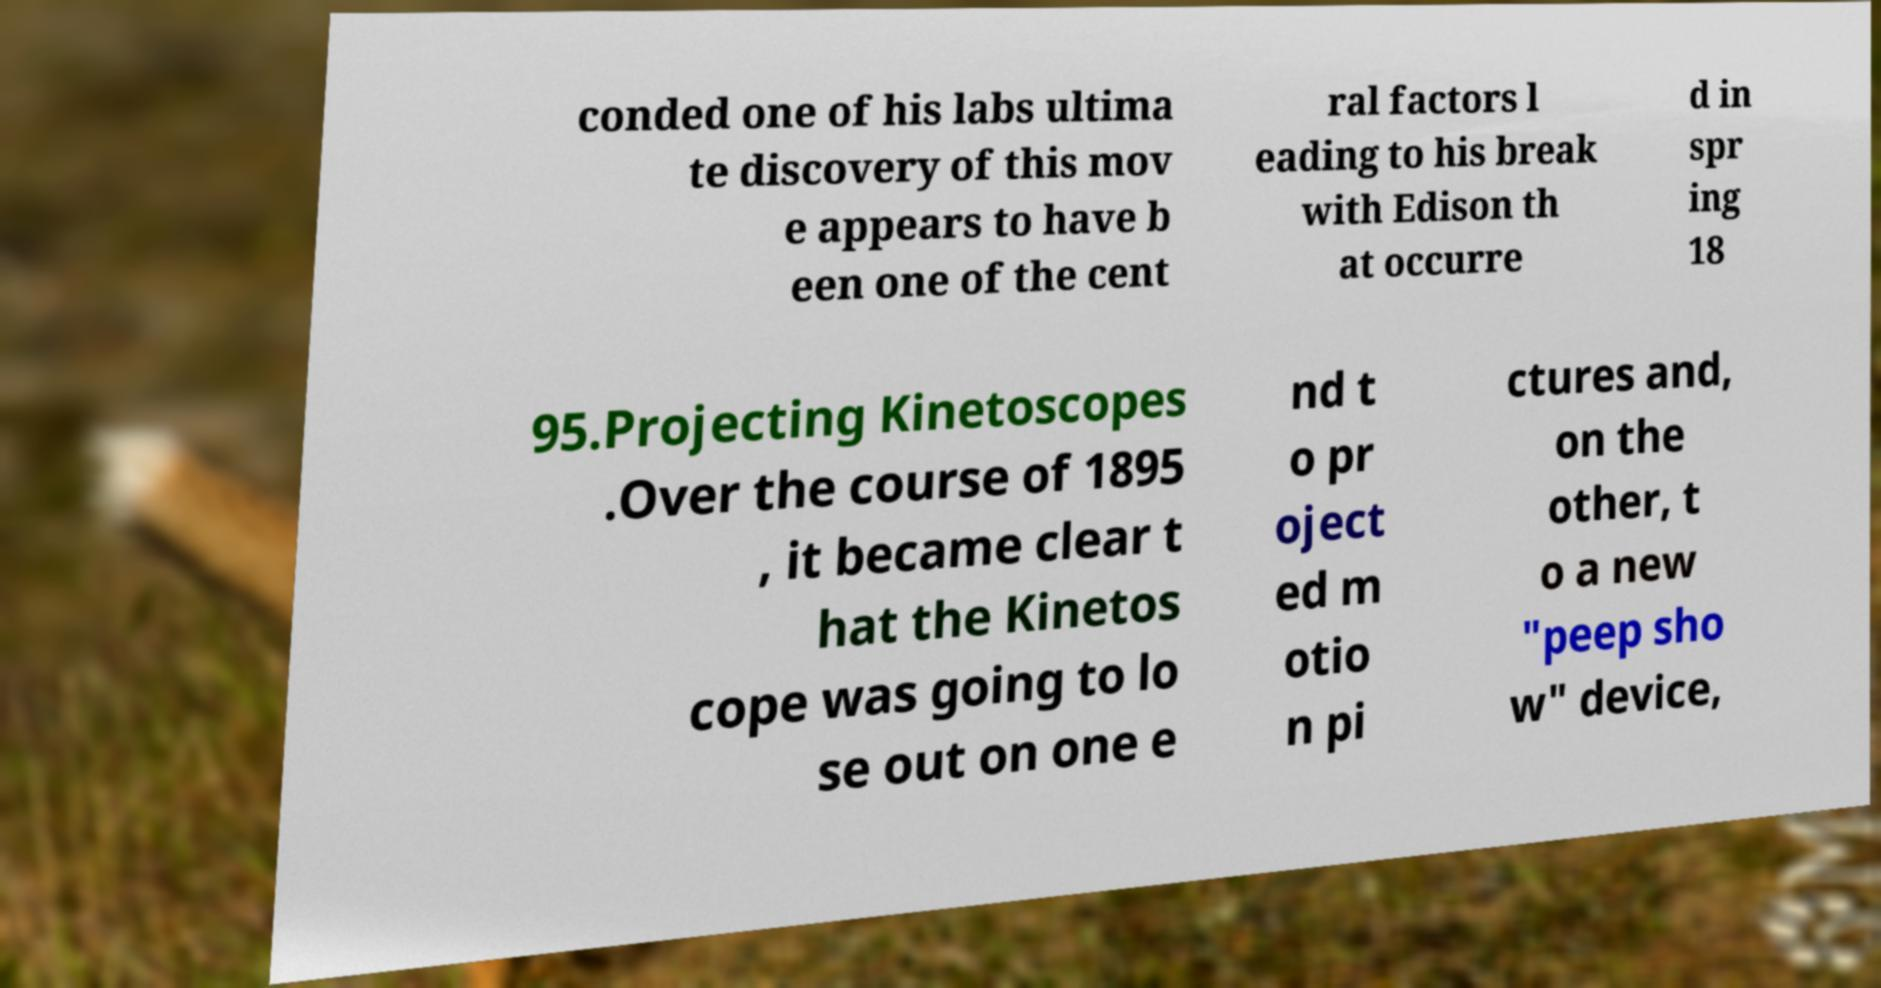Can you accurately transcribe the text from the provided image for me? conded one of his labs ultima te discovery of this mov e appears to have b een one of the cent ral factors l eading to his break with Edison th at occurre d in spr ing 18 95.Projecting Kinetoscopes .Over the course of 1895 , it became clear t hat the Kinetos cope was going to lo se out on one e nd t o pr oject ed m otio n pi ctures and, on the other, t o a new "peep sho w" device, 